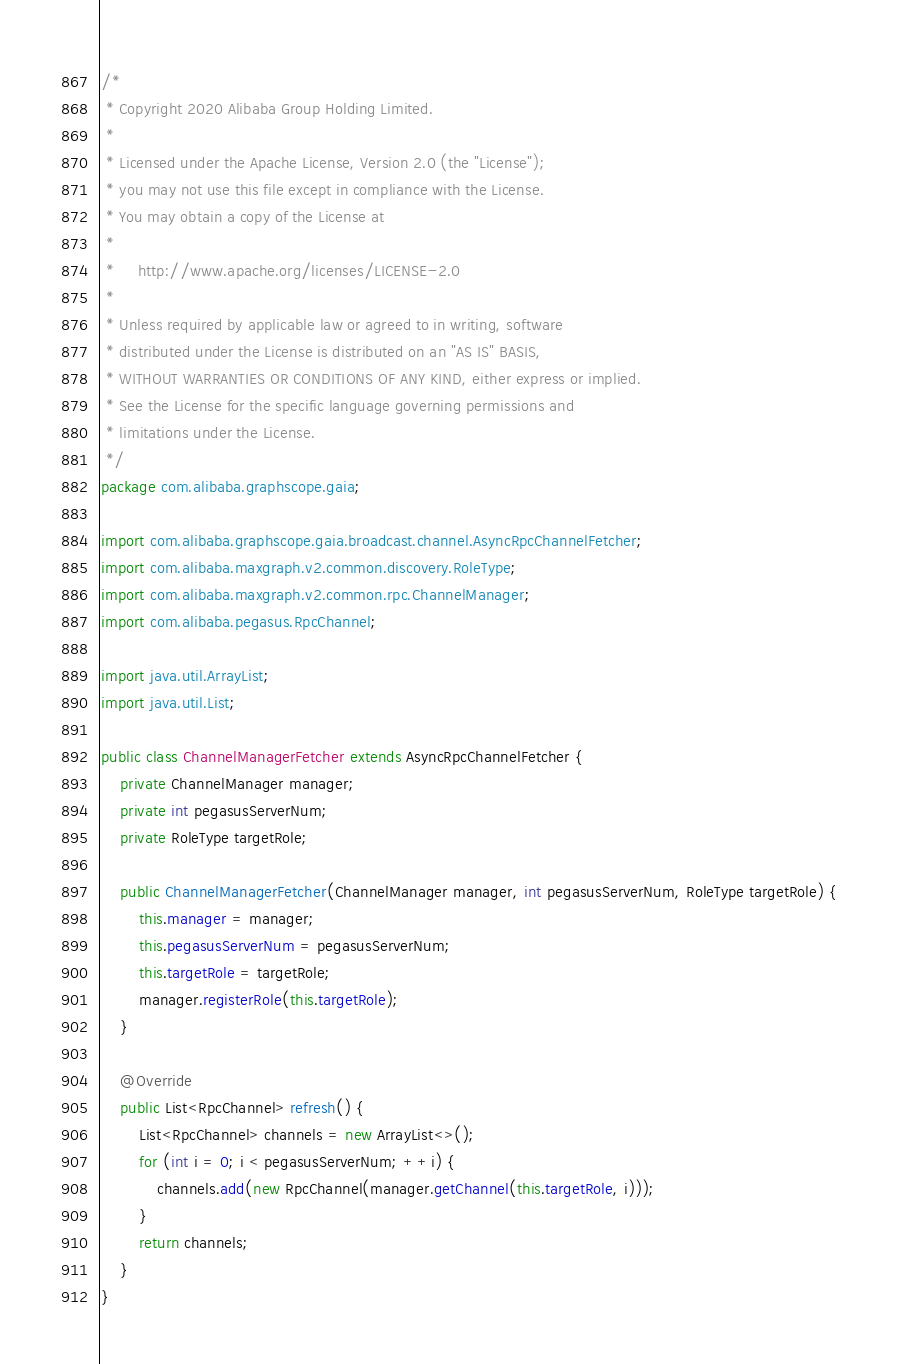Convert code to text. <code><loc_0><loc_0><loc_500><loc_500><_Java_>/*
 * Copyright 2020 Alibaba Group Holding Limited.
 *
 * Licensed under the Apache License, Version 2.0 (the "License");
 * you may not use this file except in compliance with the License.
 * You may obtain a copy of the License at
 *
 *     http://www.apache.org/licenses/LICENSE-2.0
 *
 * Unless required by applicable law or agreed to in writing, software
 * distributed under the License is distributed on an "AS IS" BASIS,
 * WITHOUT WARRANTIES OR CONDITIONS OF ANY KIND, either express or implied.
 * See the License for the specific language governing permissions and
 * limitations under the License.
 */
package com.alibaba.graphscope.gaia;

import com.alibaba.graphscope.gaia.broadcast.channel.AsyncRpcChannelFetcher;
import com.alibaba.maxgraph.v2.common.discovery.RoleType;
import com.alibaba.maxgraph.v2.common.rpc.ChannelManager;
import com.alibaba.pegasus.RpcChannel;

import java.util.ArrayList;
import java.util.List;

public class ChannelManagerFetcher extends AsyncRpcChannelFetcher {
    private ChannelManager manager;
    private int pegasusServerNum;
    private RoleType targetRole;

    public ChannelManagerFetcher(ChannelManager manager, int pegasusServerNum, RoleType targetRole) {
        this.manager = manager;
        this.pegasusServerNum = pegasusServerNum;
        this.targetRole = targetRole;
        manager.registerRole(this.targetRole);
    }

    @Override
    public List<RpcChannel> refresh() {
        List<RpcChannel> channels = new ArrayList<>();
        for (int i = 0; i < pegasusServerNum; ++i) {
            channels.add(new RpcChannel(manager.getChannel(this.targetRole, i)));
        }
        return channels;
    }
}
</code> 